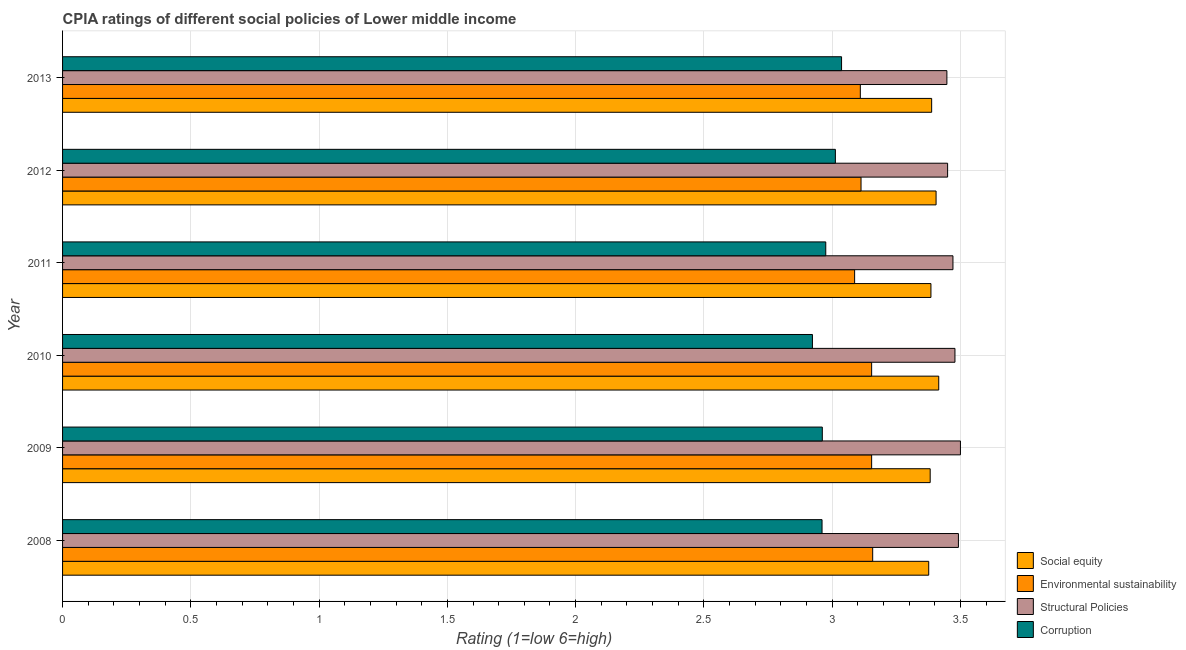How many different coloured bars are there?
Your answer should be very brief. 4. Are the number of bars per tick equal to the number of legend labels?
Keep it short and to the point. Yes. Are the number of bars on each tick of the Y-axis equal?
Ensure brevity in your answer.  Yes. How many bars are there on the 1st tick from the top?
Offer a very short reply. 4. What is the label of the 4th group of bars from the top?
Offer a terse response. 2010. What is the cpia rating of corruption in 2010?
Provide a succinct answer. 2.92. Across all years, what is the maximum cpia rating of corruption?
Provide a succinct answer. 3.04. Across all years, what is the minimum cpia rating of structural policies?
Make the answer very short. 3.45. In which year was the cpia rating of social equity maximum?
Your response must be concise. 2010. In which year was the cpia rating of structural policies minimum?
Provide a short and direct response. 2013. What is the total cpia rating of environmental sustainability in the graph?
Keep it short and to the point. 18.78. What is the difference between the cpia rating of corruption in 2012 and that in 2013?
Your answer should be compact. -0.02. What is the difference between the cpia rating of corruption in 2010 and the cpia rating of structural policies in 2012?
Provide a short and direct response. -0.53. What is the average cpia rating of corruption per year?
Your answer should be compact. 2.98. In the year 2013, what is the difference between the cpia rating of structural policies and cpia rating of corruption?
Keep it short and to the point. 0.41. What is the difference between the highest and the second highest cpia rating of environmental sustainability?
Your response must be concise. 0. Is the sum of the cpia rating of structural policies in 2009 and 2012 greater than the maximum cpia rating of environmental sustainability across all years?
Provide a short and direct response. Yes. What does the 3rd bar from the top in 2013 represents?
Make the answer very short. Environmental sustainability. What does the 2nd bar from the bottom in 2011 represents?
Make the answer very short. Environmental sustainability. Is it the case that in every year, the sum of the cpia rating of social equity and cpia rating of environmental sustainability is greater than the cpia rating of structural policies?
Keep it short and to the point. Yes. What is the difference between two consecutive major ticks on the X-axis?
Make the answer very short. 0.5. Are the values on the major ticks of X-axis written in scientific E-notation?
Keep it short and to the point. No. Does the graph contain any zero values?
Provide a short and direct response. No. How many legend labels are there?
Provide a succinct answer. 4. What is the title of the graph?
Make the answer very short. CPIA ratings of different social policies of Lower middle income. What is the label or title of the X-axis?
Your answer should be compact. Rating (1=low 6=high). What is the Rating (1=low 6=high) in Social equity in 2008?
Give a very brief answer. 3.38. What is the Rating (1=low 6=high) of Environmental sustainability in 2008?
Provide a succinct answer. 3.16. What is the Rating (1=low 6=high) in Structural Policies in 2008?
Keep it short and to the point. 3.49. What is the Rating (1=low 6=high) in Corruption in 2008?
Keep it short and to the point. 2.96. What is the Rating (1=low 6=high) in Social equity in 2009?
Offer a terse response. 3.38. What is the Rating (1=low 6=high) of Environmental sustainability in 2009?
Give a very brief answer. 3.15. What is the Rating (1=low 6=high) in Structural Policies in 2009?
Offer a terse response. 3.5. What is the Rating (1=low 6=high) in Corruption in 2009?
Ensure brevity in your answer.  2.96. What is the Rating (1=low 6=high) in Social equity in 2010?
Offer a very short reply. 3.42. What is the Rating (1=low 6=high) of Environmental sustainability in 2010?
Keep it short and to the point. 3.15. What is the Rating (1=low 6=high) of Structural Policies in 2010?
Your answer should be very brief. 3.48. What is the Rating (1=low 6=high) of Corruption in 2010?
Make the answer very short. 2.92. What is the Rating (1=low 6=high) of Social equity in 2011?
Provide a succinct answer. 3.38. What is the Rating (1=low 6=high) of Environmental sustainability in 2011?
Your response must be concise. 3.09. What is the Rating (1=low 6=high) in Structural Policies in 2011?
Give a very brief answer. 3.47. What is the Rating (1=low 6=high) of Corruption in 2011?
Offer a very short reply. 2.98. What is the Rating (1=low 6=high) in Social equity in 2012?
Ensure brevity in your answer.  3.4. What is the Rating (1=low 6=high) of Environmental sustainability in 2012?
Keep it short and to the point. 3.11. What is the Rating (1=low 6=high) in Structural Policies in 2012?
Your answer should be compact. 3.45. What is the Rating (1=low 6=high) of Corruption in 2012?
Your response must be concise. 3.01. What is the Rating (1=low 6=high) of Social equity in 2013?
Make the answer very short. 3.39. What is the Rating (1=low 6=high) in Environmental sustainability in 2013?
Your answer should be compact. 3.11. What is the Rating (1=low 6=high) in Structural Policies in 2013?
Keep it short and to the point. 3.45. What is the Rating (1=low 6=high) of Corruption in 2013?
Your response must be concise. 3.04. Across all years, what is the maximum Rating (1=low 6=high) in Social equity?
Provide a succinct answer. 3.42. Across all years, what is the maximum Rating (1=low 6=high) in Environmental sustainability?
Keep it short and to the point. 3.16. Across all years, what is the maximum Rating (1=low 6=high) of Corruption?
Provide a short and direct response. 3.04. Across all years, what is the minimum Rating (1=low 6=high) of Social equity?
Make the answer very short. 3.38. Across all years, what is the minimum Rating (1=low 6=high) of Environmental sustainability?
Your answer should be very brief. 3.09. Across all years, what is the minimum Rating (1=low 6=high) in Structural Policies?
Keep it short and to the point. 3.45. Across all years, what is the minimum Rating (1=low 6=high) in Corruption?
Provide a succinct answer. 2.92. What is the total Rating (1=low 6=high) in Social equity in the graph?
Provide a succinct answer. 20.35. What is the total Rating (1=low 6=high) in Environmental sustainability in the graph?
Keep it short and to the point. 18.78. What is the total Rating (1=low 6=high) in Structural Policies in the graph?
Ensure brevity in your answer.  20.84. What is the total Rating (1=low 6=high) in Corruption in the graph?
Provide a short and direct response. 17.87. What is the difference between the Rating (1=low 6=high) of Social equity in 2008 and that in 2009?
Keep it short and to the point. -0.01. What is the difference between the Rating (1=low 6=high) of Environmental sustainability in 2008 and that in 2009?
Make the answer very short. 0. What is the difference between the Rating (1=low 6=high) of Structural Policies in 2008 and that in 2009?
Give a very brief answer. -0.01. What is the difference between the Rating (1=low 6=high) in Corruption in 2008 and that in 2009?
Your answer should be very brief. -0. What is the difference between the Rating (1=low 6=high) in Social equity in 2008 and that in 2010?
Give a very brief answer. -0.04. What is the difference between the Rating (1=low 6=high) of Environmental sustainability in 2008 and that in 2010?
Provide a succinct answer. 0. What is the difference between the Rating (1=low 6=high) in Structural Policies in 2008 and that in 2010?
Offer a terse response. 0.01. What is the difference between the Rating (1=low 6=high) of Corruption in 2008 and that in 2010?
Your response must be concise. 0.04. What is the difference between the Rating (1=low 6=high) in Social equity in 2008 and that in 2011?
Your answer should be compact. -0.01. What is the difference between the Rating (1=low 6=high) in Environmental sustainability in 2008 and that in 2011?
Your response must be concise. 0.07. What is the difference between the Rating (1=low 6=high) of Structural Policies in 2008 and that in 2011?
Give a very brief answer. 0.02. What is the difference between the Rating (1=low 6=high) in Corruption in 2008 and that in 2011?
Ensure brevity in your answer.  -0.01. What is the difference between the Rating (1=low 6=high) in Social equity in 2008 and that in 2012?
Give a very brief answer. -0.03. What is the difference between the Rating (1=low 6=high) in Environmental sustainability in 2008 and that in 2012?
Offer a very short reply. 0.05. What is the difference between the Rating (1=low 6=high) of Structural Policies in 2008 and that in 2012?
Keep it short and to the point. 0.04. What is the difference between the Rating (1=low 6=high) in Corruption in 2008 and that in 2012?
Offer a very short reply. -0.05. What is the difference between the Rating (1=low 6=high) in Social equity in 2008 and that in 2013?
Make the answer very short. -0.01. What is the difference between the Rating (1=low 6=high) of Environmental sustainability in 2008 and that in 2013?
Offer a very short reply. 0.05. What is the difference between the Rating (1=low 6=high) in Structural Policies in 2008 and that in 2013?
Give a very brief answer. 0.04. What is the difference between the Rating (1=low 6=high) of Corruption in 2008 and that in 2013?
Your answer should be very brief. -0.08. What is the difference between the Rating (1=low 6=high) in Social equity in 2009 and that in 2010?
Your answer should be compact. -0.03. What is the difference between the Rating (1=low 6=high) in Structural Policies in 2009 and that in 2010?
Your answer should be compact. 0.02. What is the difference between the Rating (1=low 6=high) in Corruption in 2009 and that in 2010?
Keep it short and to the point. 0.04. What is the difference between the Rating (1=low 6=high) in Social equity in 2009 and that in 2011?
Your answer should be compact. -0. What is the difference between the Rating (1=low 6=high) of Environmental sustainability in 2009 and that in 2011?
Keep it short and to the point. 0.07. What is the difference between the Rating (1=low 6=high) of Structural Policies in 2009 and that in 2011?
Keep it short and to the point. 0.03. What is the difference between the Rating (1=low 6=high) in Corruption in 2009 and that in 2011?
Provide a short and direct response. -0.01. What is the difference between the Rating (1=low 6=high) in Social equity in 2009 and that in 2012?
Provide a short and direct response. -0.02. What is the difference between the Rating (1=low 6=high) in Environmental sustainability in 2009 and that in 2012?
Offer a terse response. 0.04. What is the difference between the Rating (1=low 6=high) in Structural Policies in 2009 and that in 2012?
Provide a succinct answer. 0.05. What is the difference between the Rating (1=low 6=high) of Corruption in 2009 and that in 2012?
Offer a terse response. -0.05. What is the difference between the Rating (1=low 6=high) of Social equity in 2009 and that in 2013?
Offer a terse response. -0.01. What is the difference between the Rating (1=low 6=high) of Environmental sustainability in 2009 and that in 2013?
Keep it short and to the point. 0.04. What is the difference between the Rating (1=low 6=high) in Structural Policies in 2009 and that in 2013?
Your response must be concise. 0.05. What is the difference between the Rating (1=low 6=high) in Corruption in 2009 and that in 2013?
Offer a terse response. -0.07. What is the difference between the Rating (1=low 6=high) of Social equity in 2010 and that in 2011?
Provide a short and direct response. 0.03. What is the difference between the Rating (1=low 6=high) of Environmental sustainability in 2010 and that in 2011?
Give a very brief answer. 0.07. What is the difference between the Rating (1=low 6=high) in Structural Policies in 2010 and that in 2011?
Provide a short and direct response. 0.01. What is the difference between the Rating (1=low 6=high) in Corruption in 2010 and that in 2011?
Ensure brevity in your answer.  -0.05. What is the difference between the Rating (1=low 6=high) of Social equity in 2010 and that in 2012?
Give a very brief answer. 0.01. What is the difference between the Rating (1=low 6=high) of Environmental sustainability in 2010 and that in 2012?
Your answer should be compact. 0.04. What is the difference between the Rating (1=low 6=high) of Structural Policies in 2010 and that in 2012?
Keep it short and to the point. 0.03. What is the difference between the Rating (1=low 6=high) of Corruption in 2010 and that in 2012?
Make the answer very short. -0.09. What is the difference between the Rating (1=low 6=high) in Social equity in 2010 and that in 2013?
Your answer should be compact. 0.03. What is the difference between the Rating (1=low 6=high) of Environmental sustainability in 2010 and that in 2013?
Provide a short and direct response. 0.04. What is the difference between the Rating (1=low 6=high) in Structural Policies in 2010 and that in 2013?
Offer a very short reply. 0.03. What is the difference between the Rating (1=low 6=high) in Corruption in 2010 and that in 2013?
Give a very brief answer. -0.11. What is the difference between the Rating (1=low 6=high) of Social equity in 2011 and that in 2012?
Ensure brevity in your answer.  -0.02. What is the difference between the Rating (1=low 6=high) of Environmental sustainability in 2011 and that in 2012?
Provide a short and direct response. -0.03. What is the difference between the Rating (1=low 6=high) in Structural Policies in 2011 and that in 2012?
Ensure brevity in your answer.  0.02. What is the difference between the Rating (1=low 6=high) in Corruption in 2011 and that in 2012?
Ensure brevity in your answer.  -0.04. What is the difference between the Rating (1=low 6=high) of Social equity in 2011 and that in 2013?
Give a very brief answer. -0. What is the difference between the Rating (1=low 6=high) in Environmental sustainability in 2011 and that in 2013?
Offer a terse response. -0.02. What is the difference between the Rating (1=low 6=high) in Structural Policies in 2011 and that in 2013?
Your answer should be compact. 0.02. What is the difference between the Rating (1=low 6=high) in Corruption in 2011 and that in 2013?
Provide a short and direct response. -0.06. What is the difference between the Rating (1=low 6=high) in Social equity in 2012 and that in 2013?
Offer a very short reply. 0.02. What is the difference between the Rating (1=low 6=high) in Environmental sustainability in 2012 and that in 2013?
Your answer should be very brief. 0. What is the difference between the Rating (1=low 6=high) in Structural Policies in 2012 and that in 2013?
Give a very brief answer. 0. What is the difference between the Rating (1=low 6=high) of Corruption in 2012 and that in 2013?
Offer a very short reply. -0.02. What is the difference between the Rating (1=low 6=high) in Social equity in 2008 and the Rating (1=low 6=high) in Environmental sustainability in 2009?
Offer a terse response. 0.22. What is the difference between the Rating (1=low 6=high) in Social equity in 2008 and the Rating (1=low 6=high) in Structural Policies in 2009?
Offer a very short reply. -0.12. What is the difference between the Rating (1=low 6=high) of Social equity in 2008 and the Rating (1=low 6=high) of Corruption in 2009?
Provide a succinct answer. 0.41. What is the difference between the Rating (1=low 6=high) of Environmental sustainability in 2008 and the Rating (1=low 6=high) of Structural Policies in 2009?
Offer a very short reply. -0.34. What is the difference between the Rating (1=low 6=high) in Environmental sustainability in 2008 and the Rating (1=low 6=high) in Corruption in 2009?
Give a very brief answer. 0.2. What is the difference between the Rating (1=low 6=high) of Structural Policies in 2008 and the Rating (1=low 6=high) of Corruption in 2009?
Ensure brevity in your answer.  0.53. What is the difference between the Rating (1=low 6=high) of Social equity in 2008 and the Rating (1=low 6=high) of Environmental sustainability in 2010?
Your answer should be very brief. 0.22. What is the difference between the Rating (1=low 6=high) of Social equity in 2008 and the Rating (1=low 6=high) of Structural Policies in 2010?
Provide a short and direct response. -0.1. What is the difference between the Rating (1=low 6=high) in Social equity in 2008 and the Rating (1=low 6=high) in Corruption in 2010?
Offer a terse response. 0.45. What is the difference between the Rating (1=low 6=high) of Environmental sustainability in 2008 and the Rating (1=low 6=high) of Structural Policies in 2010?
Your response must be concise. -0.32. What is the difference between the Rating (1=low 6=high) of Environmental sustainability in 2008 and the Rating (1=low 6=high) of Corruption in 2010?
Your answer should be very brief. 0.23. What is the difference between the Rating (1=low 6=high) of Structural Policies in 2008 and the Rating (1=low 6=high) of Corruption in 2010?
Provide a short and direct response. 0.57. What is the difference between the Rating (1=low 6=high) of Social equity in 2008 and the Rating (1=low 6=high) of Environmental sustainability in 2011?
Make the answer very short. 0.29. What is the difference between the Rating (1=low 6=high) of Social equity in 2008 and the Rating (1=low 6=high) of Structural Policies in 2011?
Offer a terse response. -0.09. What is the difference between the Rating (1=low 6=high) in Social equity in 2008 and the Rating (1=low 6=high) in Corruption in 2011?
Keep it short and to the point. 0.4. What is the difference between the Rating (1=low 6=high) of Environmental sustainability in 2008 and the Rating (1=low 6=high) of Structural Policies in 2011?
Your answer should be very brief. -0.31. What is the difference between the Rating (1=low 6=high) of Environmental sustainability in 2008 and the Rating (1=low 6=high) of Corruption in 2011?
Provide a short and direct response. 0.18. What is the difference between the Rating (1=low 6=high) in Structural Policies in 2008 and the Rating (1=low 6=high) in Corruption in 2011?
Your answer should be very brief. 0.52. What is the difference between the Rating (1=low 6=high) in Social equity in 2008 and the Rating (1=low 6=high) in Environmental sustainability in 2012?
Make the answer very short. 0.26. What is the difference between the Rating (1=low 6=high) of Social equity in 2008 and the Rating (1=low 6=high) of Structural Policies in 2012?
Provide a succinct answer. -0.07. What is the difference between the Rating (1=low 6=high) in Social equity in 2008 and the Rating (1=low 6=high) in Corruption in 2012?
Your response must be concise. 0.36. What is the difference between the Rating (1=low 6=high) in Environmental sustainability in 2008 and the Rating (1=low 6=high) in Structural Policies in 2012?
Give a very brief answer. -0.29. What is the difference between the Rating (1=low 6=high) in Environmental sustainability in 2008 and the Rating (1=low 6=high) in Corruption in 2012?
Offer a terse response. 0.15. What is the difference between the Rating (1=low 6=high) in Structural Policies in 2008 and the Rating (1=low 6=high) in Corruption in 2012?
Make the answer very short. 0.48. What is the difference between the Rating (1=low 6=high) of Social equity in 2008 and the Rating (1=low 6=high) of Environmental sustainability in 2013?
Your answer should be compact. 0.27. What is the difference between the Rating (1=low 6=high) of Social equity in 2008 and the Rating (1=low 6=high) of Structural Policies in 2013?
Give a very brief answer. -0.07. What is the difference between the Rating (1=low 6=high) in Social equity in 2008 and the Rating (1=low 6=high) in Corruption in 2013?
Offer a very short reply. 0.34. What is the difference between the Rating (1=low 6=high) in Environmental sustainability in 2008 and the Rating (1=low 6=high) in Structural Policies in 2013?
Ensure brevity in your answer.  -0.29. What is the difference between the Rating (1=low 6=high) of Environmental sustainability in 2008 and the Rating (1=low 6=high) of Corruption in 2013?
Your answer should be compact. 0.12. What is the difference between the Rating (1=low 6=high) in Structural Policies in 2008 and the Rating (1=low 6=high) in Corruption in 2013?
Give a very brief answer. 0.46. What is the difference between the Rating (1=low 6=high) of Social equity in 2009 and the Rating (1=low 6=high) of Environmental sustainability in 2010?
Ensure brevity in your answer.  0.23. What is the difference between the Rating (1=low 6=high) of Social equity in 2009 and the Rating (1=low 6=high) of Structural Policies in 2010?
Your answer should be very brief. -0.1. What is the difference between the Rating (1=low 6=high) in Social equity in 2009 and the Rating (1=low 6=high) in Corruption in 2010?
Provide a succinct answer. 0.46. What is the difference between the Rating (1=low 6=high) in Environmental sustainability in 2009 and the Rating (1=low 6=high) in Structural Policies in 2010?
Provide a short and direct response. -0.32. What is the difference between the Rating (1=low 6=high) of Environmental sustainability in 2009 and the Rating (1=low 6=high) of Corruption in 2010?
Provide a short and direct response. 0.23. What is the difference between the Rating (1=low 6=high) in Structural Policies in 2009 and the Rating (1=low 6=high) in Corruption in 2010?
Your answer should be compact. 0.58. What is the difference between the Rating (1=low 6=high) of Social equity in 2009 and the Rating (1=low 6=high) of Environmental sustainability in 2011?
Make the answer very short. 0.29. What is the difference between the Rating (1=low 6=high) of Social equity in 2009 and the Rating (1=low 6=high) of Structural Policies in 2011?
Offer a terse response. -0.09. What is the difference between the Rating (1=low 6=high) of Social equity in 2009 and the Rating (1=low 6=high) of Corruption in 2011?
Provide a short and direct response. 0.41. What is the difference between the Rating (1=low 6=high) in Environmental sustainability in 2009 and the Rating (1=low 6=high) in Structural Policies in 2011?
Your answer should be very brief. -0.32. What is the difference between the Rating (1=low 6=high) of Environmental sustainability in 2009 and the Rating (1=low 6=high) of Corruption in 2011?
Keep it short and to the point. 0.18. What is the difference between the Rating (1=low 6=high) of Structural Policies in 2009 and the Rating (1=low 6=high) of Corruption in 2011?
Provide a short and direct response. 0.53. What is the difference between the Rating (1=low 6=high) of Social equity in 2009 and the Rating (1=low 6=high) of Environmental sustainability in 2012?
Provide a succinct answer. 0.27. What is the difference between the Rating (1=low 6=high) of Social equity in 2009 and the Rating (1=low 6=high) of Structural Policies in 2012?
Provide a succinct answer. -0.07. What is the difference between the Rating (1=low 6=high) in Social equity in 2009 and the Rating (1=low 6=high) in Corruption in 2012?
Keep it short and to the point. 0.37. What is the difference between the Rating (1=low 6=high) of Environmental sustainability in 2009 and the Rating (1=low 6=high) of Structural Policies in 2012?
Your answer should be compact. -0.3. What is the difference between the Rating (1=low 6=high) in Environmental sustainability in 2009 and the Rating (1=low 6=high) in Corruption in 2012?
Provide a succinct answer. 0.14. What is the difference between the Rating (1=low 6=high) in Structural Policies in 2009 and the Rating (1=low 6=high) in Corruption in 2012?
Make the answer very short. 0.49. What is the difference between the Rating (1=low 6=high) of Social equity in 2009 and the Rating (1=low 6=high) of Environmental sustainability in 2013?
Your response must be concise. 0.27. What is the difference between the Rating (1=low 6=high) of Social equity in 2009 and the Rating (1=low 6=high) of Structural Policies in 2013?
Your answer should be very brief. -0.07. What is the difference between the Rating (1=low 6=high) of Social equity in 2009 and the Rating (1=low 6=high) of Corruption in 2013?
Keep it short and to the point. 0.35. What is the difference between the Rating (1=low 6=high) of Environmental sustainability in 2009 and the Rating (1=low 6=high) of Structural Policies in 2013?
Make the answer very short. -0.29. What is the difference between the Rating (1=low 6=high) in Environmental sustainability in 2009 and the Rating (1=low 6=high) in Corruption in 2013?
Keep it short and to the point. 0.12. What is the difference between the Rating (1=low 6=high) in Structural Policies in 2009 and the Rating (1=low 6=high) in Corruption in 2013?
Provide a succinct answer. 0.46. What is the difference between the Rating (1=low 6=high) of Social equity in 2010 and the Rating (1=low 6=high) of Environmental sustainability in 2011?
Your response must be concise. 0.33. What is the difference between the Rating (1=low 6=high) of Social equity in 2010 and the Rating (1=low 6=high) of Structural Policies in 2011?
Ensure brevity in your answer.  -0.06. What is the difference between the Rating (1=low 6=high) in Social equity in 2010 and the Rating (1=low 6=high) in Corruption in 2011?
Your response must be concise. 0.44. What is the difference between the Rating (1=low 6=high) of Environmental sustainability in 2010 and the Rating (1=low 6=high) of Structural Policies in 2011?
Your response must be concise. -0.32. What is the difference between the Rating (1=low 6=high) in Environmental sustainability in 2010 and the Rating (1=low 6=high) in Corruption in 2011?
Keep it short and to the point. 0.18. What is the difference between the Rating (1=low 6=high) of Structural Policies in 2010 and the Rating (1=low 6=high) of Corruption in 2011?
Offer a terse response. 0.5. What is the difference between the Rating (1=low 6=high) of Social equity in 2010 and the Rating (1=low 6=high) of Environmental sustainability in 2012?
Ensure brevity in your answer.  0.3. What is the difference between the Rating (1=low 6=high) of Social equity in 2010 and the Rating (1=low 6=high) of Structural Policies in 2012?
Your answer should be very brief. -0.03. What is the difference between the Rating (1=low 6=high) of Social equity in 2010 and the Rating (1=low 6=high) of Corruption in 2012?
Offer a terse response. 0.4. What is the difference between the Rating (1=low 6=high) in Environmental sustainability in 2010 and the Rating (1=low 6=high) in Structural Policies in 2012?
Your answer should be very brief. -0.3. What is the difference between the Rating (1=low 6=high) in Environmental sustainability in 2010 and the Rating (1=low 6=high) in Corruption in 2012?
Your answer should be very brief. 0.14. What is the difference between the Rating (1=low 6=high) of Structural Policies in 2010 and the Rating (1=low 6=high) of Corruption in 2012?
Provide a short and direct response. 0.47. What is the difference between the Rating (1=low 6=high) of Social equity in 2010 and the Rating (1=low 6=high) of Environmental sustainability in 2013?
Offer a terse response. 0.31. What is the difference between the Rating (1=low 6=high) of Social equity in 2010 and the Rating (1=low 6=high) of Structural Policies in 2013?
Provide a succinct answer. -0.03. What is the difference between the Rating (1=low 6=high) of Social equity in 2010 and the Rating (1=low 6=high) of Corruption in 2013?
Make the answer very short. 0.38. What is the difference between the Rating (1=low 6=high) in Environmental sustainability in 2010 and the Rating (1=low 6=high) in Structural Policies in 2013?
Ensure brevity in your answer.  -0.29. What is the difference between the Rating (1=low 6=high) in Environmental sustainability in 2010 and the Rating (1=low 6=high) in Corruption in 2013?
Offer a terse response. 0.12. What is the difference between the Rating (1=low 6=high) of Structural Policies in 2010 and the Rating (1=low 6=high) of Corruption in 2013?
Your answer should be compact. 0.44. What is the difference between the Rating (1=low 6=high) of Social equity in 2011 and the Rating (1=low 6=high) of Environmental sustainability in 2012?
Offer a very short reply. 0.27. What is the difference between the Rating (1=low 6=high) in Social equity in 2011 and the Rating (1=low 6=high) in Structural Policies in 2012?
Your response must be concise. -0.07. What is the difference between the Rating (1=low 6=high) of Social equity in 2011 and the Rating (1=low 6=high) of Corruption in 2012?
Offer a very short reply. 0.37. What is the difference between the Rating (1=low 6=high) of Environmental sustainability in 2011 and the Rating (1=low 6=high) of Structural Policies in 2012?
Ensure brevity in your answer.  -0.36. What is the difference between the Rating (1=low 6=high) of Environmental sustainability in 2011 and the Rating (1=low 6=high) of Corruption in 2012?
Your response must be concise. 0.07. What is the difference between the Rating (1=low 6=high) in Structural Policies in 2011 and the Rating (1=low 6=high) in Corruption in 2012?
Your answer should be compact. 0.46. What is the difference between the Rating (1=low 6=high) of Social equity in 2011 and the Rating (1=low 6=high) of Environmental sustainability in 2013?
Make the answer very short. 0.28. What is the difference between the Rating (1=low 6=high) of Social equity in 2011 and the Rating (1=low 6=high) of Structural Policies in 2013?
Provide a short and direct response. -0.06. What is the difference between the Rating (1=low 6=high) of Social equity in 2011 and the Rating (1=low 6=high) of Corruption in 2013?
Offer a terse response. 0.35. What is the difference between the Rating (1=low 6=high) of Environmental sustainability in 2011 and the Rating (1=low 6=high) of Structural Policies in 2013?
Your answer should be very brief. -0.36. What is the difference between the Rating (1=low 6=high) in Environmental sustainability in 2011 and the Rating (1=low 6=high) in Corruption in 2013?
Your answer should be compact. 0.05. What is the difference between the Rating (1=low 6=high) in Structural Policies in 2011 and the Rating (1=low 6=high) in Corruption in 2013?
Provide a succinct answer. 0.43. What is the difference between the Rating (1=low 6=high) in Social equity in 2012 and the Rating (1=low 6=high) in Environmental sustainability in 2013?
Provide a succinct answer. 0.3. What is the difference between the Rating (1=low 6=high) in Social equity in 2012 and the Rating (1=low 6=high) in Structural Policies in 2013?
Provide a succinct answer. -0.04. What is the difference between the Rating (1=low 6=high) of Social equity in 2012 and the Rating (1=low 6=high) of Corruption in 2013?
Make the answer very short. 0.37. What is the difference between the Rating (1=low 6=high) in Environmental sustainability in 2012 and the Rating (1=low 6=high) in Structural Policies in 2013?
Your answer should be compact. -0.33. What is the difference between the Rating (1=low 6=high) in Environmental sustainability in 2012 and the Rating (1=low 6=high) in Corruption in 2013?
Give a very brief answer. 0.08. What is the difference between the Rating (1=low 6=high) of Structural Policies in 2012 and the Rating (1=low 6=high) of Corruption in 2013?
Your response must be concise. 0.41. What is the average Rating (1=low 6=high) in Social equity per year?
Your answer should be compact. 3.39. What is the average Rating (1=low 6=high) in Environmental sustainability per year?
Offer a terse response. 3.13. What is the average Rating (1=low 6=high) of Structural Policies per year?
Your answer should be compact. 3.47. What is the average Rating (1=low 6=high) in Corruption per year?
Your answer should be very brief. 2.98. In the year 2008, what is the difference between the Rating (1=low 6=high) of Social equity and Rating (1=low 6=high) of Environmental sustainability?
Offer a very short reply. 0.22. In the year 2008, what is the difference between the Rating (1=low 6=high) in Social equity and Rating (1=low 6=high) in Structural Policies?
Your answer should be compact. -0.12. In the year 2008, what is the difference between the Rating (1=low 6=high) in Social equity and Rating (1=low 6=high) in Corruption?
Provide a short and direct response. 0.42. In the year 2008, what is the difference between the Rating (1=low 6=high) in Environmental sustainability and Rating (1=low 6=high) in Structural Policies?
Your response must be concise. -0.33. In the year 2008, what is the difference between the Rating (1=low 6=high) in Environmental sustainability and Rating (1=low 6=high) in Corruption?
Give a very brief answer. 0.2. In the year 2008, what is the difference between the Rating (1=low 6=high) of Structural Policies and Rating (1=low 6=high) of Corruption?
Make the answer very short. 0.53. In the year 2009, what is the difference between the Rating (1=low 6=high) in Social equity and Rating (1=low 6=high) in Environmental sustainability?
Offer a very short reply. 0.23. In the year 2009, what is the difference between the Rating (1=low 6=high) in Social equity and Rating (1=low 6=high) in Structural Policies?
Offer a very short reply. -0.12. In the year 2009, what is the difference between the Rating (1=low 6=high) of Social equity and Rating (1=low 6=high) of Corruption?
Provide a succinct answer. 0.42. In the year 2009, what is the difference between the Rating (1=low 6=high) of Environmental sustainability and Rating (1=low 6=high) of Structural Policies?
Your answer should be very brief. -0.35. In the year 2009, what is the difference between the Rating (1=low 6=high) in Environmental sustainability and Rating (1=low 6=high) in Corruption?
Your answer should be compact. 0.19. In the year 2009, what is the difference between the Rating (1=low 6=high) in Structural Policies and Rating (1=low 6=high) in Corruption?
Offer a very short reply. 0.54. In the year 2010, what is the difference between the Rating (1=low 6=high) in Social equity and Rating (1=low 6=high) in Environmental sustainability?
Offer a terse response. 0.26. In the year 2010, what is the difference between the Rating (1=low 6=high) in Social equity and Rating (1=low 6=high) in Structural Policies?
Your answer should be compact. -0.06. In the year 2010, what is the difference between the Rating (1=low 6=high) of Social equity and Rating (1=low 6=high) of Corruption?
Keep it short and to the point. 0.49. In the year 2010, what is the difference between the Rating (1=low 6=high) of Environmental sustainability and Rating (1=low 6=high) of Structural Policies?
Offer a very short reply. -0.32. In the year 2010, what is the difference between the Rating (1=low 6=high) of Environmental sustainability and Rating (1=low 6=high) of Corruption?
Ensure brevity in your answer.  0.23. In the year 2010, what is the difference between the Rating (1=low 6=high) of Structural Policies and Rating (1=low 6=high) of Corruption?
Provide a short and direct response. 0.56. In the year 2011, what is the difference between the Rating (1=low 6=high) of Social equity and Rating (1=low 6=high) of Environmental sustainability?
Keep it short and to the point. 0.3. In the year 2011, what is the difference between the Rating (1=low 6=high) in Social equity and Rating (1=low 6=high) in Structural Policies?
Give a very brief answer. -0.09. In the year 2011, what is the difference between the Rating (1=low 6=high) in Social equity and Rating (1=low 6=high) in Corruption?
Offer a terse response. 0.41. In the year 2011, what is the difference between the Rating (1=low 6=high) in Environmental sustainability and Rating (1=low 6=high) in Structural Policies?
Your answer should be very brief. -0.38. In the year 2011, what is the difference between the Rating (1=low 6=high) in Environmental sustainability and Rating (1=low 6=high) in Corruption?
Provide a succinct answer. 0.11. In the year 2011, what is the difference between the Rating (1=low 6=high) in Structural Policies and Rating (1=low 6=high) in Corruption?
Make the answer very short. 0.5. In the year 2012, what is the difference between the Rating (1=low 6=high) of Social equity and Rating (1=low 6=high) of Environmental sustainability?
Provide a succinct answer. 0.29. In the year 2012, what is the difference between the Rating (1=low 6=high) in Social equity and Rating (1=low 6=high) in Structural Policies?
Offer a very short reply. -0.04. In the year 2012, what is the difference between the Rating (1=low 6=high) of Social equity and Rating (1=low 6=high) of Corruption?
Offer a terse response. 0.39. In the year 2012, what is the difference between the Rating (1=low 6=high) of Environmental sustainability and Rating (1=low 6=high) of Structural Policies?
Provide a succinct answer. -0.34. In the year 2012, what is the difference between the Rating (1=low 6=high) in Structural Policies and Rating (1=low 6=high) in Corruption?
Your answer should be very brief. 0.44. In the year 2013, what is the difference between the Rating (1=low 6=high) of Social equity and Rating (1=low 6=high) of Environmental sustainability?
Give a very brief answer. 0.28. In the year 2013, what is the difference between the Rating (1=low 6=high) of Social equity and Rating (1=low 6=high) of Structural Policies?
Ensure brevity in your answer.  -0.06. In the year 2013, what is the difference between the Rating (1=low 6=high) of Social equity and Rating (1=low 6=high) of Corruption?
Make the answer very short. 0.35. In the year 2013, what is the difference between the Rating (1=low 6=high) of Environmental sustainability and Rating (1=low 6=high) of Structural Policies?
Give a very brief answer. -0.34. In the year 2013, what is the difference between the Rating (1=low 6=high) of Environmental sustainability and Rating (1=low 6=high) of Corruption?
Ensure brevity in your answer.  0.07. In the year 2013, what is the difference between the Rating (1=low 6=high) of Structural Policies and Rating (1=low 6=high) of Corruption?
Your answer should be very brief. 0.41. What is the ratio of the Rating (1=low 6=high) in Structural Policies in 2008 to that in 2009?
Your answer should be very brief. 1. What is the ratio of the Rating (1=low 6=high) in Structural Policies in 2008 to that in 2010?
Keep it short and to the point. 1. What is the ratio of the Rating (1=low 6=high) in Corruption in 2008 to that in 2010?
Provide a succinct answer. 1.01. What is the ratio of the Rating (1=low 6=high) of Social equity in 2008 to that in 2011?
Keep it short and to the point. 1. What is the ratio of the Rating (1=low 6=high) in Environmental sustainability in 2008 to that in 2011?
Give a very brief answer. 1.02. What is the ratio of the Rating (1=low 6=high) in Environmental sustainability in 2008 to that in 2012?
Provide a short and direct response. 1.01. What is the ratio of the Rating (1=low 6=high) of Structural Policies in 2008 to that in 2012?
Your response must be concise. 1.01. What is the ratio of the Rating (1=low 6=high) in Corruption in 2008 to that in 2012?
Offer a terse response. 0.98. What is the ratio of the Rating (1=low 6=high) in Social equity in 2008 to that in 2013?
Your response must be concise. 1. What is the ratio of the Rating (1=low 6=high) in Environmental sustainability in 2008 to that in 2013?
Provide a short and direct response. 1.02. What is the ratio of the Rating (1=low 6=high) of Structural Policies in 2008 to that in 2013?
Provide a succinct answer. 1.01. What is the ratio of the Rating (1=low 6=high) in Corruption in 2008 to that in 2013?
Offer a terse response. 0.97. What is the ratio of the Rating (1=low 6=high) in Social equity in 2009 to that in 2010?
Your answer should be very brief. 0.99. What is the ratio of the Rating (1=low 6=high) in Corruption in 2009 to that in 2010?
Keep it short and to the point. 1.01. What is the ratio of the Rating (1=low 6=high) in Social equity in 2009 to that in 2011?
Keep it short and to the point. 1. What is the ratio of the Rating (1=low 6=high) of Environmental sustainability in 2009 to that in 2011?
Provide a short and direct response. 1.02. What is the ratio of the Rating (1=low 6=high) of Structural Policies in 2009 to that in 2011?
Offer a terse response. 1.01. What is the ratio of the Rating (1=low 6=high) of Corruption in 2009 to that in 2011?
Make the answer very short. 1. What is the ratio of the Rating (1=low 6=high) of Environmental sustainability in 2009 to that in 2012?
Provide a short and direct response. 1.01. What is the ratio of the Rating (1=low 6=high) in Structural Policies in 2009 to that in 2012?
Give a very brief answer. 1.01. What is the ratio of the Rating (1=low 6=high) of Corruption in 2009 to that in 2012?
Your response must be concise. 0.98. What is the ratio of the Rating (1=low 6=high) of Environmental sustainability in 2009 to that in 2013?
Provide a short and direct response. 1.01. What is the ratio of the Rating (1=low 6=high) of Structural Policies in 2009 to that in 2013?
Your answer should be very brief. 1.02. What is the ratio of the Rating (1=low 6=high) of Corruption in 2009 to that in 2013?
Ensure brevity in your answer.  0.98. What is the ratio of the Rating (1=low 6=high) of Environmental sustainability in 2010 to that in 2011?
Your answer should be compact. 1.02. What is the ratio of the Rating (1=low 6=high) in Structural Policies in 2010 to that in 2011?
Provide a short and direct response. 1. What is the ratio of the Rating (1=low 6=high) of Corruption in 2010 to that in 2011?
Make the answer very short. 0.98. What is the ratio of the Rating (1=low 6=high) in Environmental sustainability in 2010 to that in 2012?
Your answer should be very brief. 1.01. What is the ratio of the Rating (1=low 6=high) of Structural Policies in 2010 to that in 2012?
Provide a short and direct response. 1.01. What is the ratio of the Rating (1=low 6=high) of Corruption in 2010 to that in 2012?
Make the answer very short. 0.97. What is the ratio of the Rating (1=low 6=high) of Environmental sustainability in 2010 to that in 2013?
Make the answer very short. 1.01. What is the ratio of the Rating (1=low 6=high) in Structural Policies in 2010 to that in 2013?
Your response must be concise. 1.01. What is the ratio of the Rating (1=low 6=high) in Corruption in 2010 to that in 2013?
Keep it short and to the point. 0.96. What is the ratio of the Rating (1=low 6=high) in Environmental sustainability in 2011 to that in 2012?
Your response must be concise. 0.99. What is the ratio of the Rating (1=low 6=high) in Structural Policies in 2011 to that in 2012?
Offer a terse response. 1.01. What is the ratio of the Rating (1=low 6=high) of Corruption in 2011 to that in 2012?
Ensure brevity in your answer.  0.99. What is the ratio of the Rating (1=low 6=high) of Social equity in 2011 to that in 2013?
Offer a terse response. 1. What is the ratio of the Rating (1=low 6=high) of Corruption in 2011 to that in 2013?
Give a very brief answer. 0.98. What is the ratio of the Rating (1=low 6=high) of Social equity in 2012 to that in 2013?
Your answer should be compact. 1.01. What is the ratio of the Rating (1=low 6=high) in Environmental sustainability in 2012 to that in 2013?
Keep it short and to the point. 1. What is the difference between the highest and the second highest Rating (1=low 6=high) in Social equity?
Provide a short and direct response. 0.01. What is the difference between the highest and the second highest Rating (1=low 6=high) in Environmental sustainability?
Keep it short and to the point. 0. What is the difference between the highest and the second highest Rating (1=low 6=high) of Structural Policies?
Offer a very short reply. 0.01. What is the difference between the highest and the second highest Rating (1=low 6=high) in Corruption?
Your answer should be compact. 0.02. What is the difference between the highest and the lowest Rating (1=low 6=high) in Social equity?
Give a very brief answer. 0.04. What is the difference between the highest and the lowest Rating (1=low 6=high) in Environmental sustainability?
Offer a very short reply. 0.07. What is the difference between the highest and the lowest Rating (1=low 6=high) in Structural Policies?
Your answer should be very brief. 0.05. What is the difference between the highest and the lowest Rating (1=low 6=high) in Corruption?
Provide a short and direct response. 0.11. 